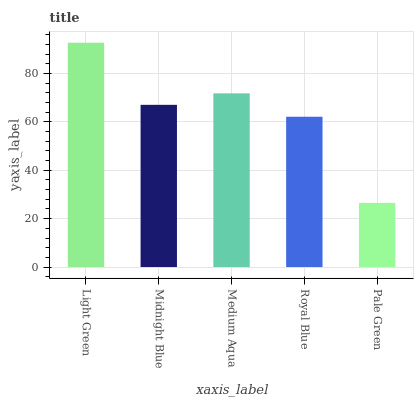Is Midnight Blue the minimum?
Answer yes or no. No. Is Midnight Blue the maximum?
Answer yes or no. No. Is Light Green greater than Midnight Blue?
Answer yes or no. Yes. Is Midnight Blue less than Light Green?
Answer yes or no. Yes. Is Midnight Blue greater than Light Green?
Answer yes or no. No. Is Light Green less than Midnight Blue?
Answer yes or no. No. Is Midnight Blue the high median?
Answer yes or no. Yes. Is Midnight Blue the low median?
Answer yes or no. Yes. Is Royal Blue the high median?
Answer yes or no. No. Is Medium Aqua the low median?
Answer yes or no. No. 